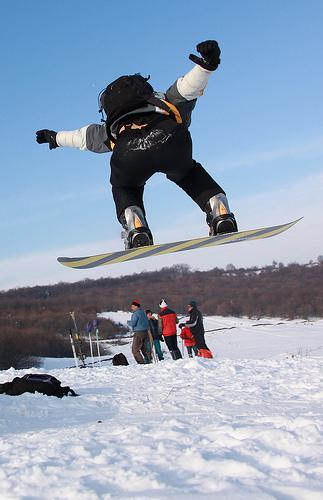Question: what is the weather like?
Choices:
A. Sunny.
B. Rainy.
C. Clear.
D. Snowing.
Answer with the letter. Answer: C Question: where was this photo taken?
Choices:
A. The hill.
B. The hotel.
C. The school.
D. On a ski slope.
Answer with the letter. Answer: D Question: what is the person doing?
Choices:
A. Snowboarding.
B. Skiing.
C. Sledding.
D. Running.
Answer with the letter. Answer: A Question: what is covering the ground?
Choices:
A. Grass.
B. Dirt.
C. Snow.
D. Mud.
Answer with the letter. Answer: C Question: who is wearing a blue jacket?
Choices:
A. Man in front.
B. Man in back.
C. Man in yard.
D. Man on porch.
Answer with the letter. Answer: B 